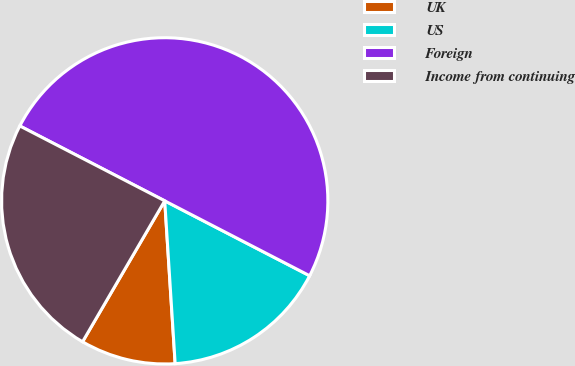Convert chart to OTSL. <chart><loc_0><loc_0><loc_500><loc_500><pie_chart><fcel>UK<fcel>US<fcel>Foreign<fcel>Income from continuing<nl><fcel>9.42%<fcel>16.39%<fcel>50.0%<fcel>24.19%<nl></chart> 